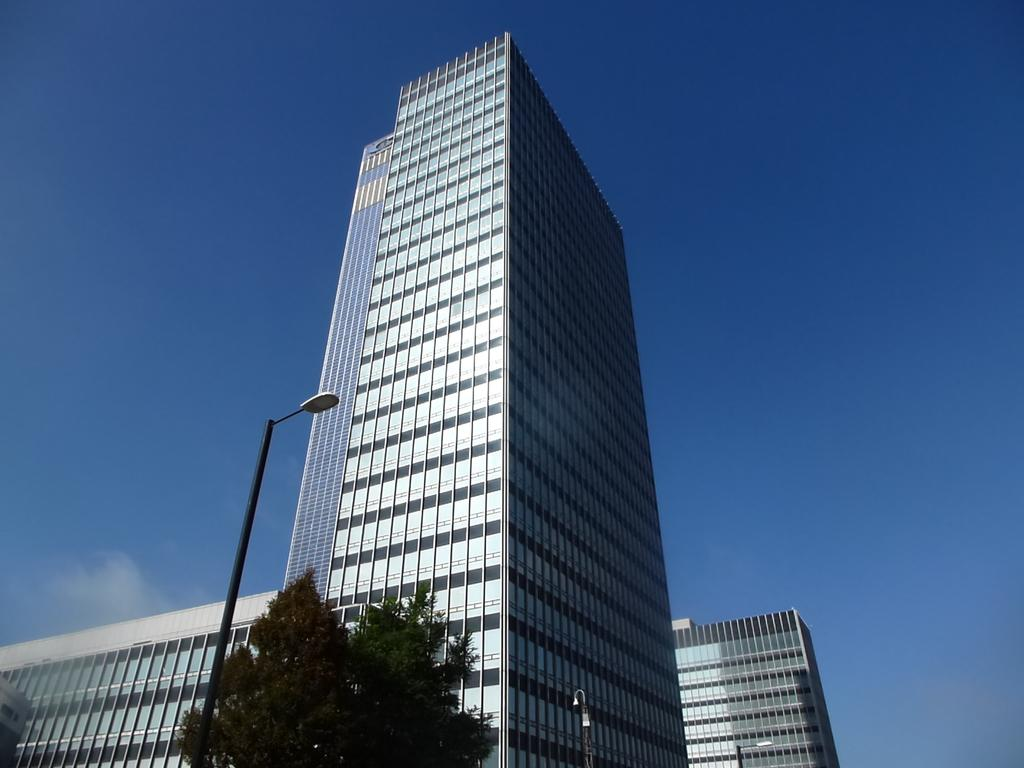What type of structures can be seen in the image? There are buildings in the image. What other natural elements are present in the image? There are trees in the image. Are there any artificial light sources visible in the image? Yes, there are street lights in the image. What is the color of the sky in the image? The sky is blue in the image. Can you see any bones sticking out of the buildings in the image? No, there are no bones visible in the image. 